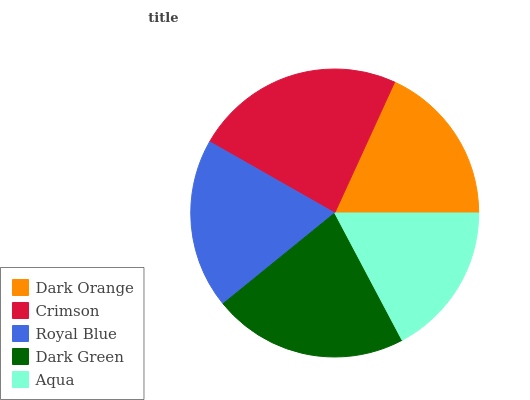Is Aqua the minimum?
Answer yes or no. Yes. Is Crimson the maximum?
Answer yes or no. Yes. Is Royal Blue the minimum?
Answer yes or no. No. Is Royal Blue the maximum?
Answer yes or no. No. Is Crimson greater than Royal Blue?
Answer yes or no. Yes. Is Royal Blue less than Crimson?
Answer yes or no. Yes. Is Royal Blue greater than Crimson?
Answer yes or no. No. Is Crimson less than Royal Blue?
Answer yes or no. No. Is Royal Blue the high median?
Answer yes or no. Yes. Is Royal Blue the low median?
Answer yes or no. Yes. Is Dark Orange the high median?
Answer yes or no. No. Is Dark Green the low median?
Answer yes or no. No. 